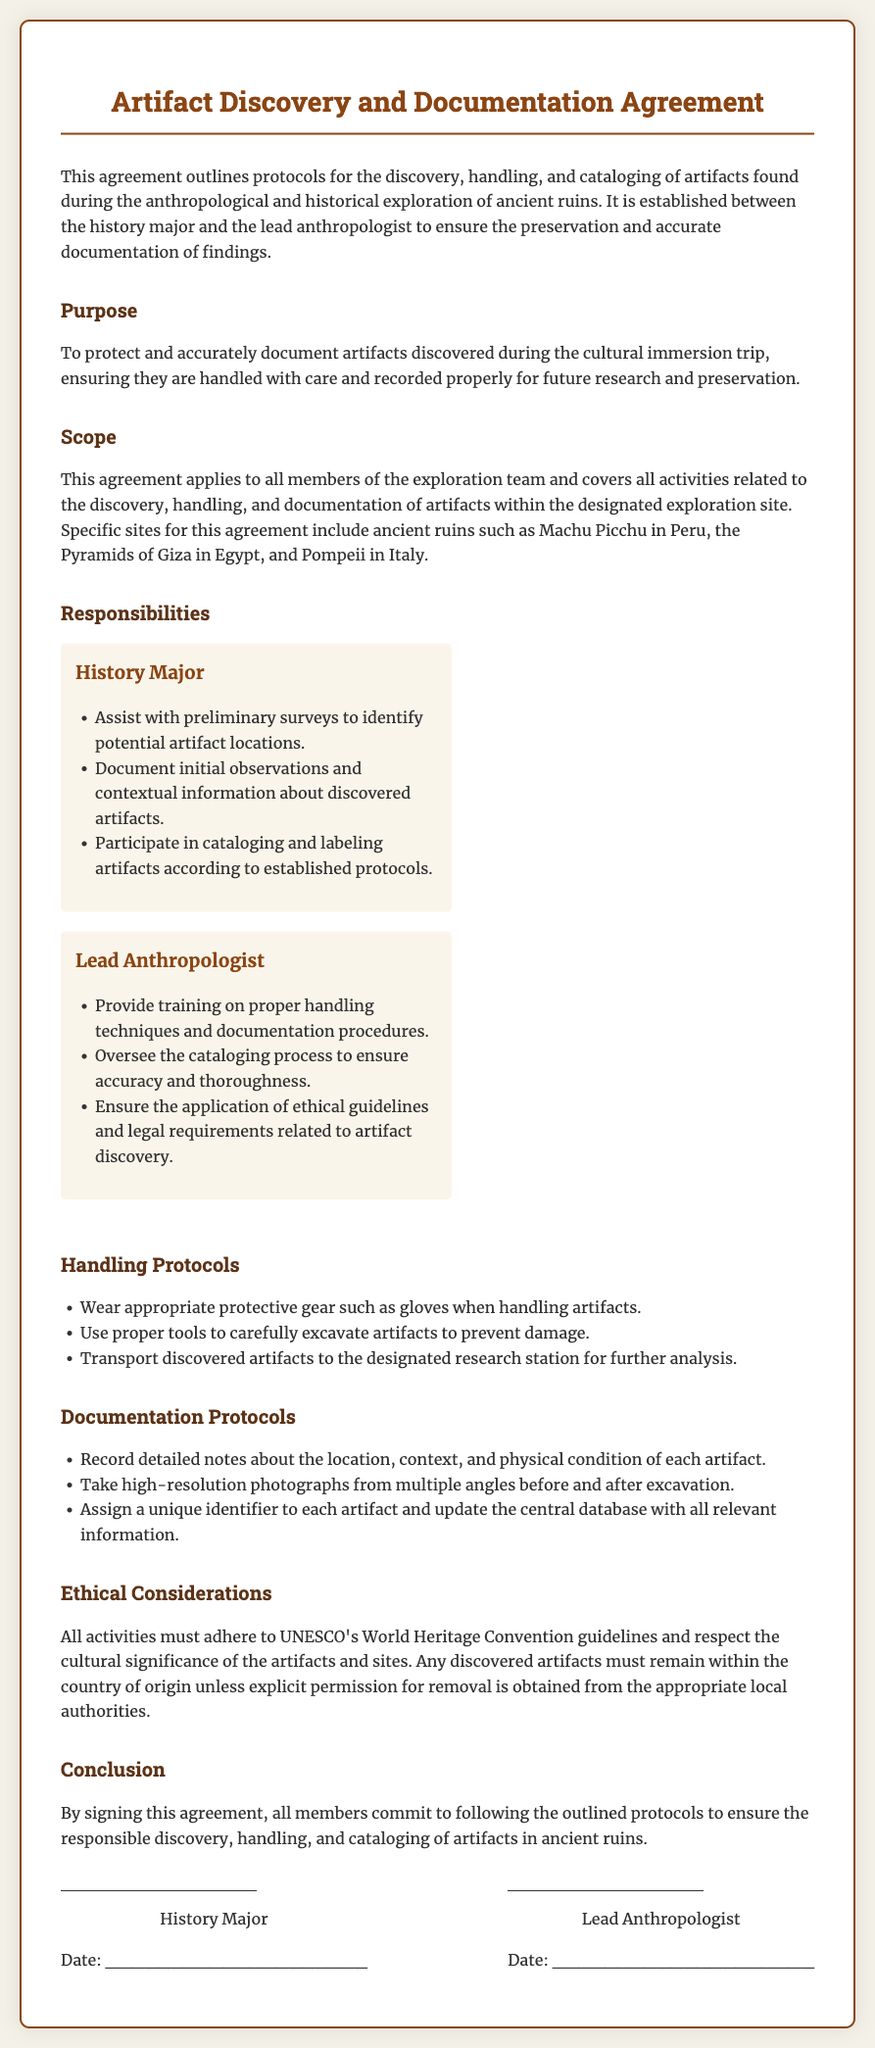What is the title of the agreement? The title of the agreement is found at the top of the document, clearly identifying its purpose.
Answer: Artifact Discovery and Documentation Agreement Who oversees the cataloging process? The document specifies who has the responsibility of ensuring accuracy and thoroughness in the cataloging process.
Answer: Lead Anthropologist What should be worn when handling artifacts? The document outlines the required protective gear for handling artifacts to prevent damage during discovery.
Answer: Protective gear such as gloves Which ancient ruins are specifically mentioned in the scope of the agreement? The document lists examples of ancient ruins where the protocols will be applied, highlighting the locations of interest.
Answer: Machu Picchu, Pyramids of Giza, Pompeii What is one of the handling protocols mentioned? The document outlines specific protocols for handling artifacts to ensure they are preserved properly.
Answer: Wear appropriate protective gear What type of photographs should be taken of the artifacts? The documentation protocols section details the type of visual documentation needed for artifacts during the process.
Answer: High-resolution photographs What ethical guidelines must all activities adhere to? The ethical considerations section of the document provides information on the necessary guidelines for conducting activities.
Answer: UNESCO's World Heritage Convention guidelines What does the history major document about artifacts? The responsibilities section indicates what tasks the history major has related to artifacts during the exploration.
Answer: Initial observations and contextual information 